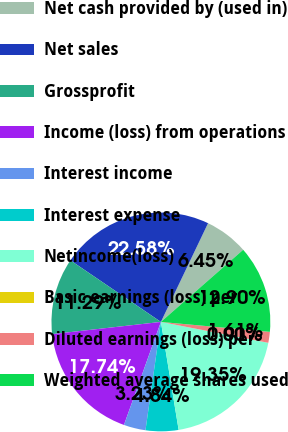Convert chart to OTSL. <chart><loc_0><loc_0><loc_500><loc_500><pie_chart><fcel>Net cash provided by (used in)<fcel>Net sales<fcel>Grossprofit<fcel>Income (loss) from operations<fcel>Interest income<fcel>Interest expense<fcel>Netincome(loss)<fcel>Basic earnings (loss) per<fcel>Diluted earnings (loss) per<fcel>Weighted average shares used<nl><fcel>6.45%<fcel>22.58%<fcel>11.29%<fcel>17.74%<fcel>3.23%<fcel>4.84%<fcel>19.35%<fcel>0.0%<fcel>1.61%<fcel>12.9%<nl></chart> 